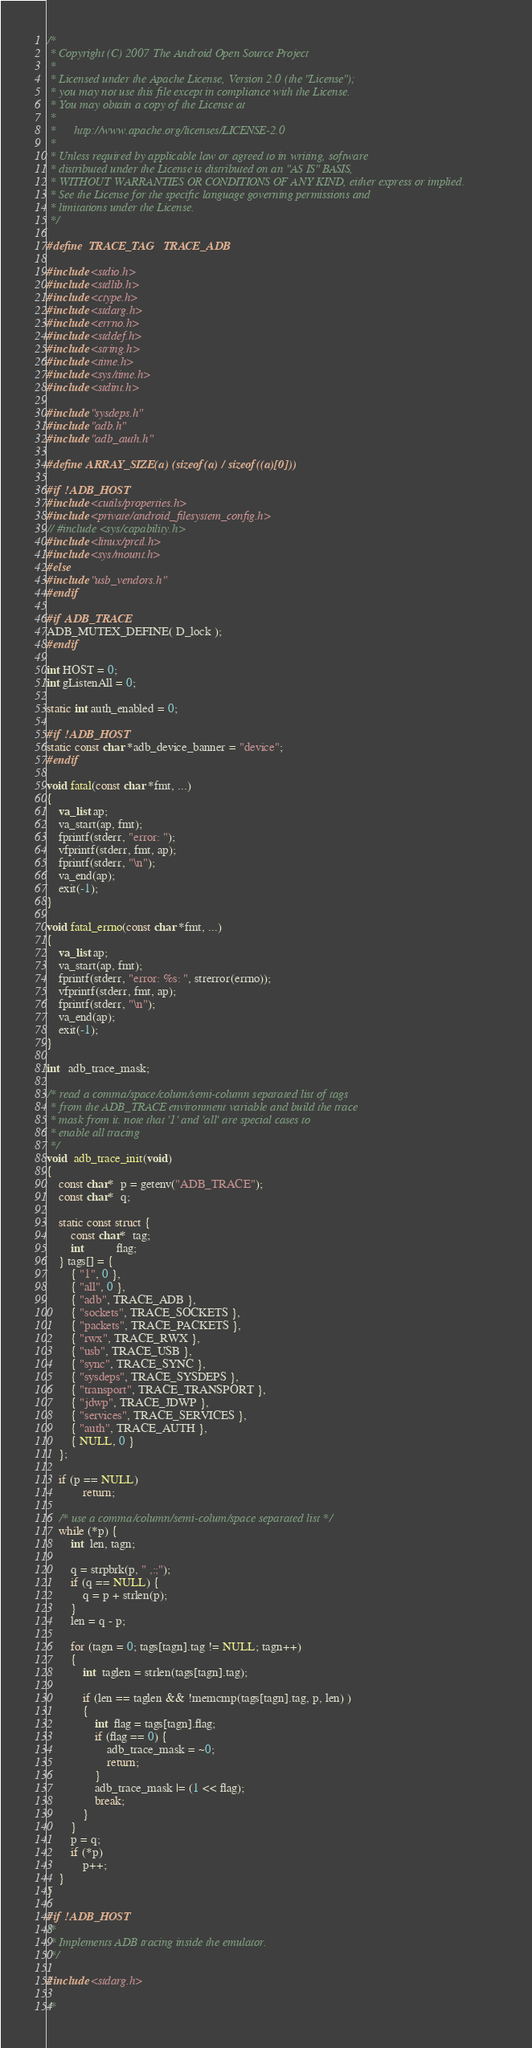Convert code to text. <code><loc_0><loc_0><loc_500><loc_500><_C_>/*
 * Copyright (C) 2007 The Android Open Source Project
 *
 * Licensed under the Apache License, Version 2.0 (the "License");
 * you may not use this file except in compliance with the License.
 * You may obtain a copy of the License at
 *
 *      http://www.apache.org/licenses/LICENSE-2.0
 *
 * Unless required by applicable law or agreed to in writing, software
 * distributed under the License is distributed on an "AS IS" BASIS,
 * WITHOUT WARRANTIES OR CONDITIONS OF ANY KIND, either express or implied.
 * See the License for the specific language governing permissions and
 * limitations under the License.
 */

#define  TRACE_TAG   TRACE_ADB

#include <stdio.h>
#include <stdlib.h>
#include <ctype.h>
#include <stdarg.h>
#include <errno.h>
#include <stddef.h>
#include <string.h>
#include <time.h>
#include <sys/time.h>
#include <stdint.h>

#include "sysdeps.h"
#include "adb.h"
#include "adb_auth.h"

#define ARRAY_SIZE(a) (sizeof(a) / sizeof((a)[0]))

#if !ADB_HOST
#include <cutils/properties.h>
#include <private/android_filesystem_config.h>
// #include <sys/capability.h>
#include <linux/prctl.h>
#include <sys/mount.h>
#else
#include "usb_vendors.h"
#endif

#if ADB_TRACE
ADB_MUTEX_DEFINE( D_lock );
#endif

int HOST = 0;
int gListenAll = 0;

static int auth_enabled = 0;

#if !ADB_HOST
static const char *adb_device_banner = "device";
#endif

void fatal(const char *fmt, ...)
{
    va_list ap;
    va_start(ap, fmt);
    fprintf(stderr, "error: ");
    vfprintf(stderr, fmt, ap);
    fprintf(stderr, "\n");
    va_end(ap);
    exit(-1);
}

void fatal_errno(const char *fmt, ...)
{
    va_list ap;
    va_start(ap, fmt);
    fprintf(stderr, "error: %s: ", strerror(errno));
    vfprintf(stderr, fmt, ap);
    fprintf(stderr, "\n");
    va_end(ap);
    exit(-1);
}

int   adb_trace_mask;

/* read a comma/space/colum/semi-column separated list of tags
 * from the ADB_TRACE environment variable and build the trace
 * mask from it. note that '1' and 'all' are special cases to
 * enable all tracing
 */
void  adb_trace_init(void)
{
    const char*  p = getenv("ADB_TRACE");
    const char*  q;

    static const struct {
        const char*  tag;
        int           flag;
    } tags[] = {
        { "1", 0 },
        { "all", 0 },
        { "adb", TRACE_ADB },
        { "sockets", TRACE_SOCKETS },
        { "packets", TRACE_PACKETS },
        { "rwx", TRACE_RWX },
        { "usb", TRACE_USB },
        { "sync", TRACE_SYNC },
        { "sysdeps", TRACE_SYSDEPS },
        { "transport", TRACE_TRANSPORT },
        { "jdwp", TRACE_JDWP },
        { "services", TRACE_SERVICES },
        { "auth", TRACE_AUTH },
        { NULL, 0 }
    };

    if (p == NULL)
            return;

    /* use a comma/column/semi-colum/space separated list */
    while (*p) {
        int  len, tagn;

        q = strpbrk(p, " ,:;");
        if (q == NULL) {
            q = p + strlen(p);
        }
        len = q - p;

        for (tagn = 0; tags[tagn].tag != NULL; tagn++)
        {
            int  taglen = strlen(tags[tagn].tag);

            if (len == taglen && !memcmp(tags[tagn].tag, p, len) )
            {
                int  flag = tags[tagn].flag;
                if (flag == 0) {
                    adb_trace_mask = ~0;
                    return;
                }
                adb_trace_mask |= (1 << flag);
                break;
            }
        }
        p = q;
        if (*p)
            p++;
    }
}

#if !ADB_HOST
/*
 * Implements ADB tracing inside the emulator.
 */

#include <stdarg.h>

/*</code> 